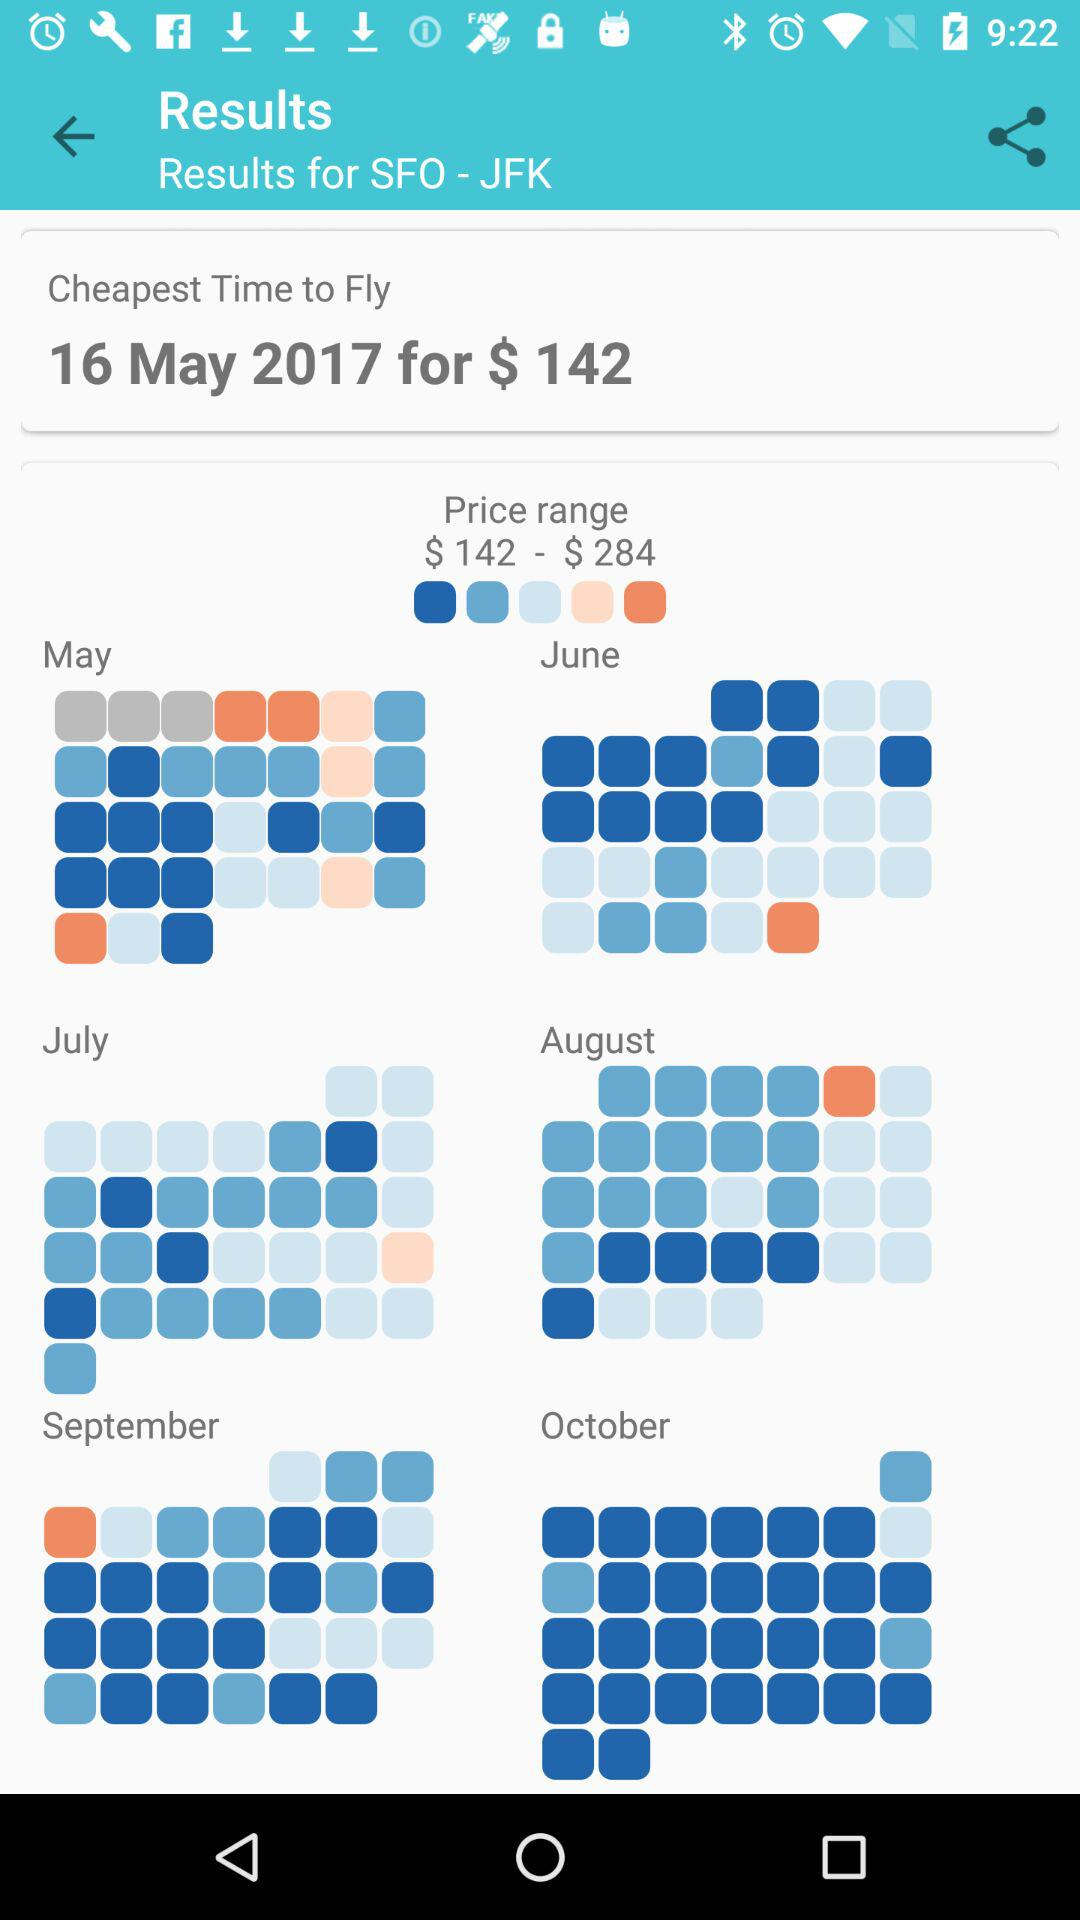What is the cheapest price to fly? The cheapest price to fly is $142. 